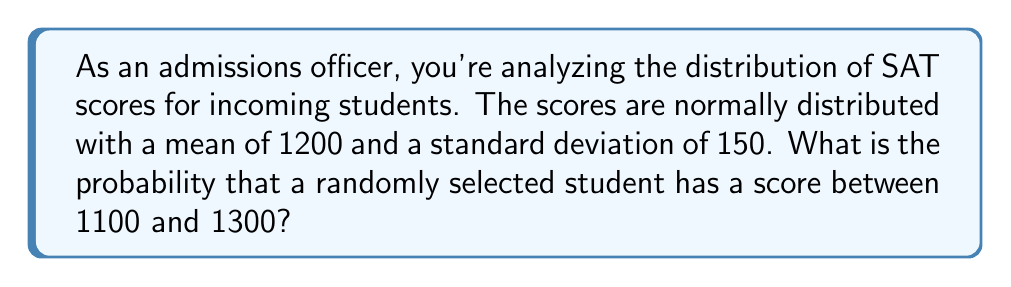Solve this math problem. To solve this problem, we'll use the properties of the normal distribution and the concept of z-scores.

Step 1: Calculate the z-scores for the given bounds.
For the lower bound (1100):
$z_1 = \frac{1100 - 1200}{150} = -\frac{2}{3}$

For the upper bound (1300):
$z_2 = \frac{1300 - 1200}{150} = \frac{2}{3}$

Step 2: Use the standard normal distribution table or a calculator to find the area under the curve between these z-scores.

The probability is equal to the area between $z_1$ and $z_2$.

$P(-\frac{2}{3} < Z < \frac{2}{3}) = P(Z < \frac{2}{3}) - P(Z < -\frac{2}{3})$

Using a standard normal distribution table or calculator:

$P(Z < \frac{2}{3}) \approx 0.7454$
$P(Z < -\frac{2}{3}) \approx 0.2546$

Step 3: Calculate the final probability.

$P(-\frac{2}{3} < Z < \frac{2}{3}) = 0.7454 - 0.2546 = 0.4908$

Therefore, the probability that a randomly selected student has a score between 1100 and 1300 is approximately 0.4908 or 49.08%.
Answer: 0.4908 